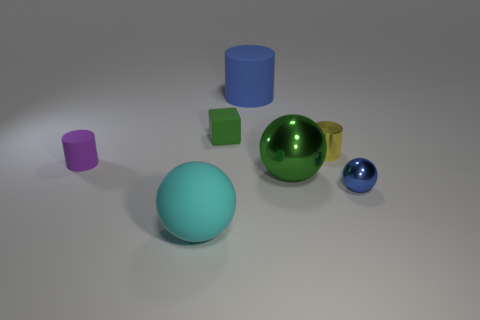What number of other objects are there of the same shape as the blue matte thing?
Provide a succinct answer. 2. Is the color of the tiny matte cylinder the same as the big ball right of the small green matte object?
Provide a succinct answer. No. Is there anything else that is the same material as the small yellow thing?
Offer a terse response. Yes. What is the shape of the green object that is in front of the small object behind the tiny yellow metal cylinder?
Provide a short and direct response. Sphere. What size is the matte thing that is the same color as the tiny metallic sphere?
Make the answer very short. Large. There is a small matte thing left of the small green matte object; is it the same shape as the big cyan rubber object?
Offer a terse response. No. Are there more large green objects behind the big metallic thing than small purple objects to the right of the green rubber cube?
Your answer should be compact. No. How many small purple matte cylinders are in front of the green object that is in front of the purple object?
Offer a very short reply. 0. What is the material of the object that is the same color as the tiny block?
Your answer should be compact. Metal. How many other things are there of the same color as the large metal object?
Your answer should be compact. 1. 